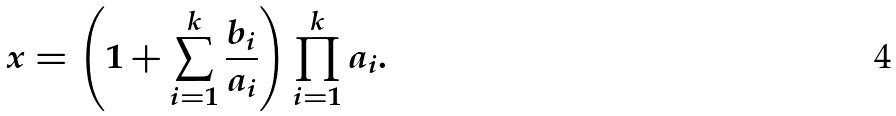Convert formula to latex. <formula><loc_0><loc_0><loc_500><loc_500>x = \left ( 1 + \sum _ { i = 1 } ^ { k } \frac { b _ { i } } { a _ { i } } \right ) \prod _ { i = 1 } ^ { k } a _ { i } .</formula> 